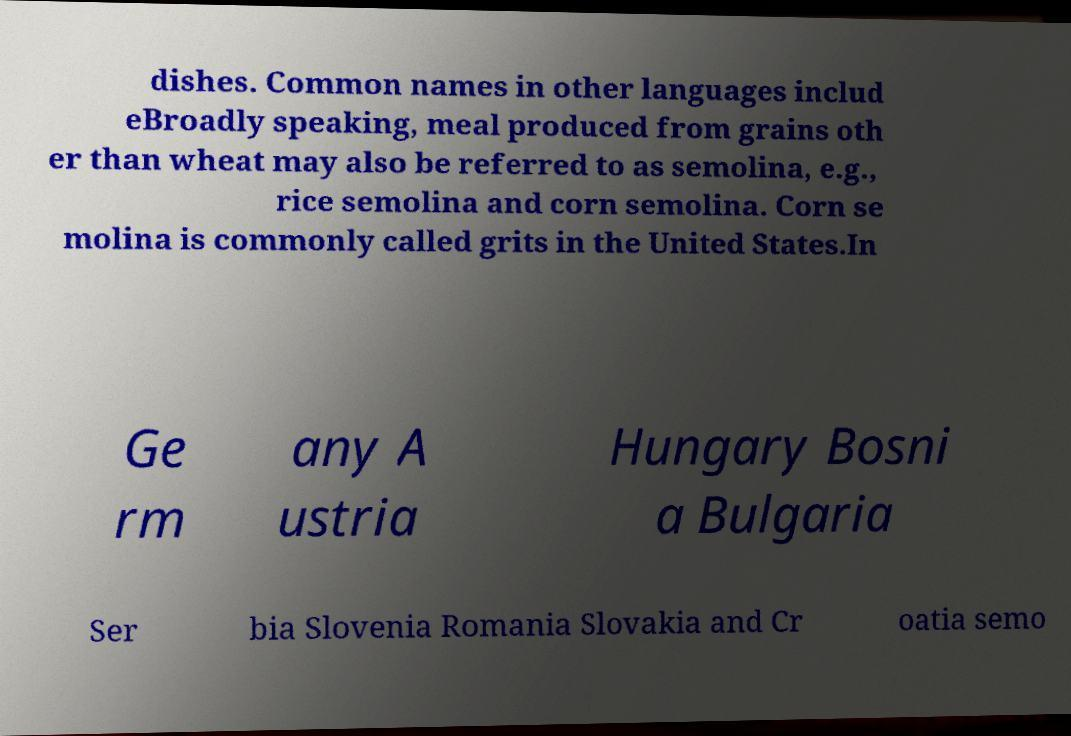Could you assist in decoding the text presented in this image and type it out clearly? dishes. Common names in other languages includ eBroadly speaking, meal produced from grains oth er than wheat may also be referred to as semolina, e.g., rice semolina and corn semolina. Corn se molina is commonly called grits in the United States.In Ge rm any A ustria Hungary Bosni a Bulgaria Ser bia Slovenia Romania Slovakia and Cr oatia semo 